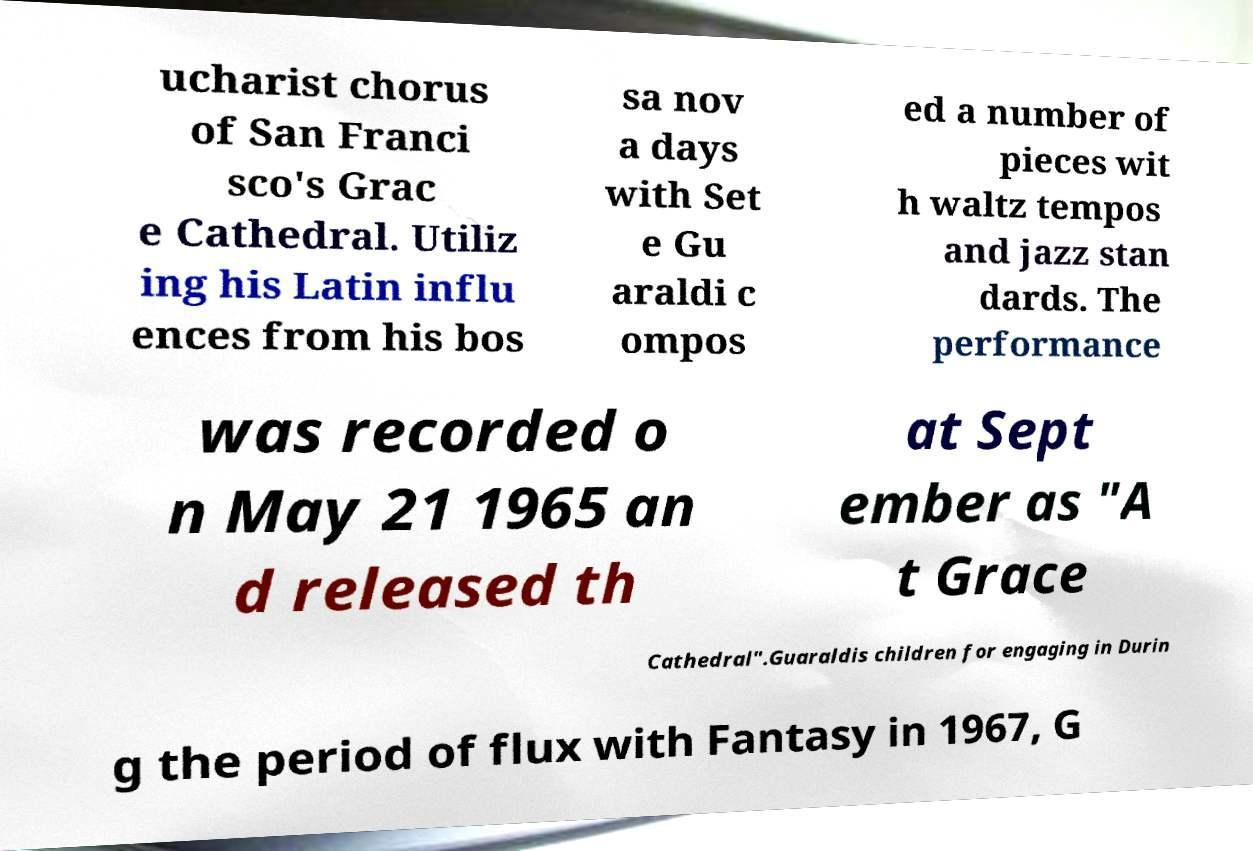Please identify and transcribe the text found in this image. ucharist chorus of San Franci sco's Grac e Cathedral. Utiliz ing his Latin influ ences from his bos sa nov a days with Set e Gu araldi c ompos ed a number of pieces wit h waltz tempos and jazz stan dards. The performance was recorded o n May 21 1965 an d released th at Sept ember as "A t Grace Cathedral".Guaraldis children for engaging in Durin g the period of flux with Fantasy in 1967, G 